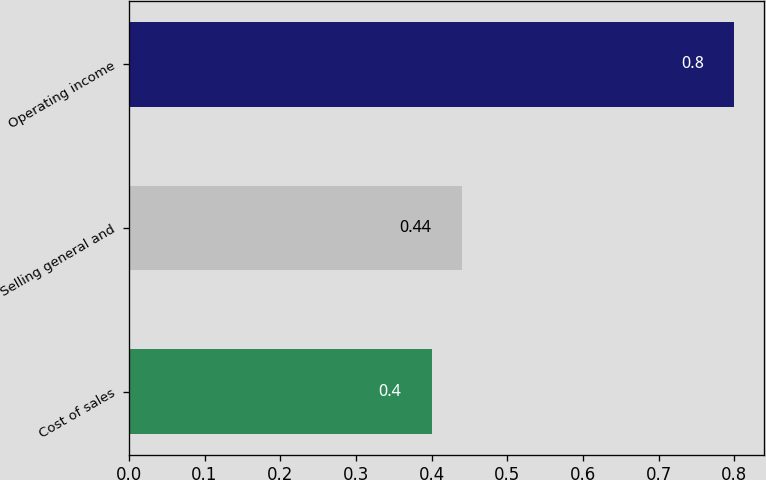Convert chart. <chart><loc_0><loc_0><loc_500><loc_500><bar_chart><fcel>Cost of sales<fcel>Selling general and<fcel>Operating income<nl><fcel>0.4<fcel>0.44<fcel>0.8<nl></chart> 